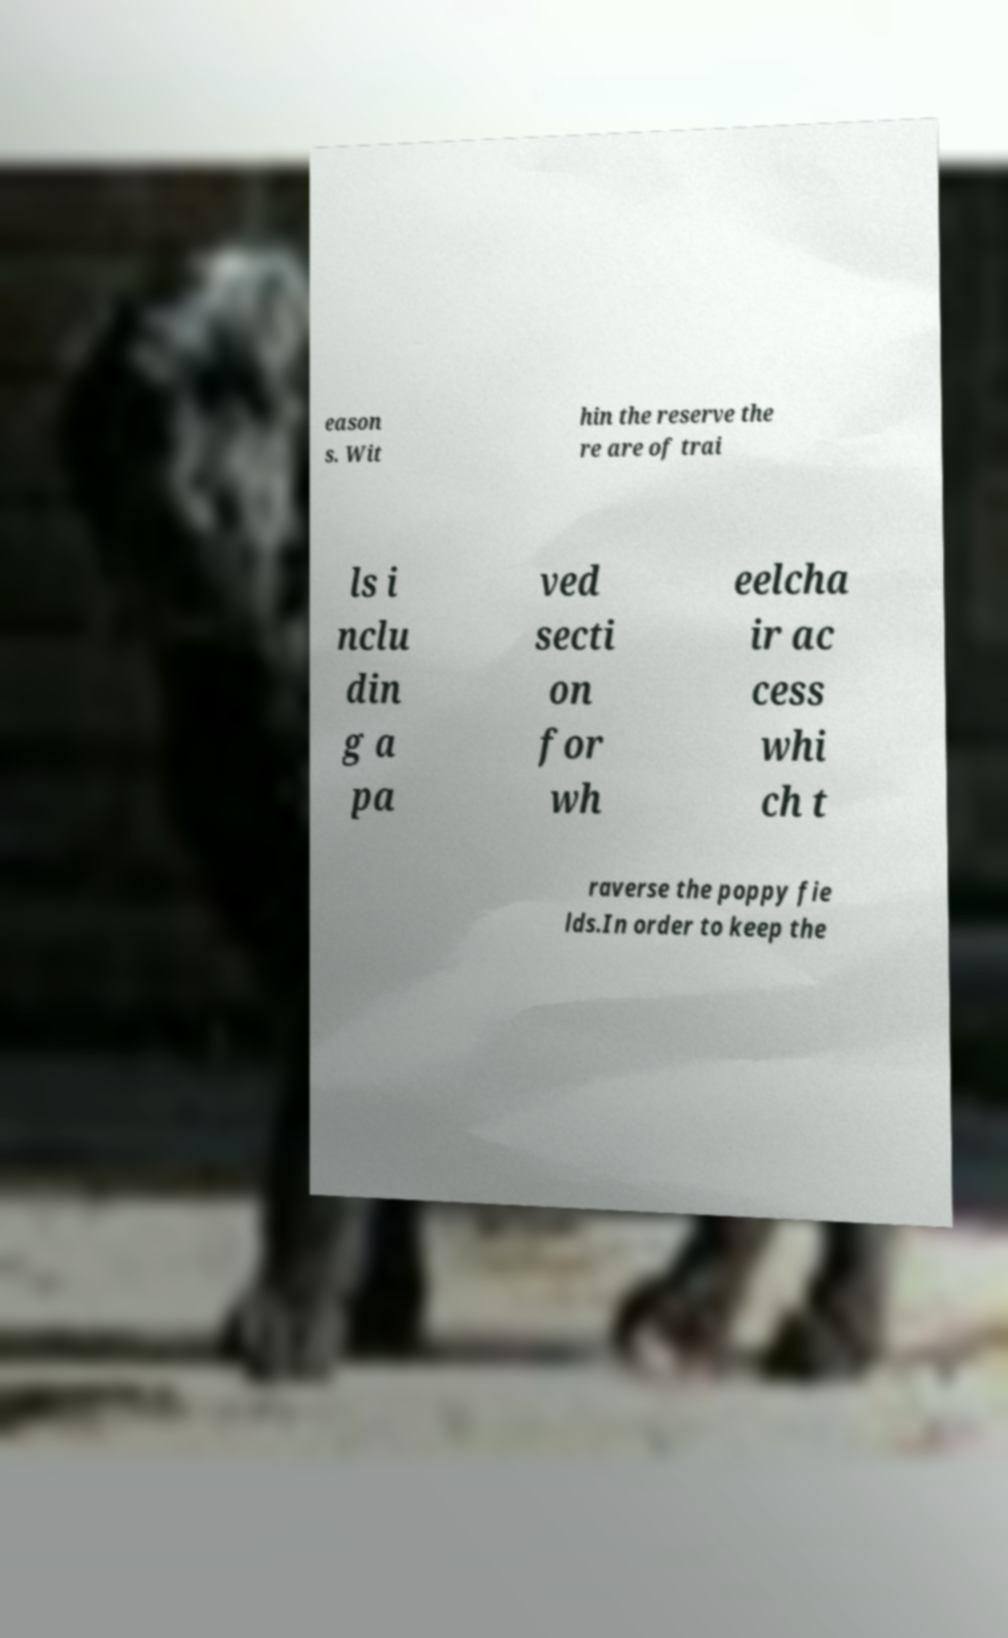There's text embedded in this image that I need extracted. Can you transcribe it verbatim? eason s. Wit hin the reserve the re are of trai ls i nclu din g a pa ved secti on for wh eelcha ir ac cess whi ch t raverse the poppy fie lds.In order to keep the 